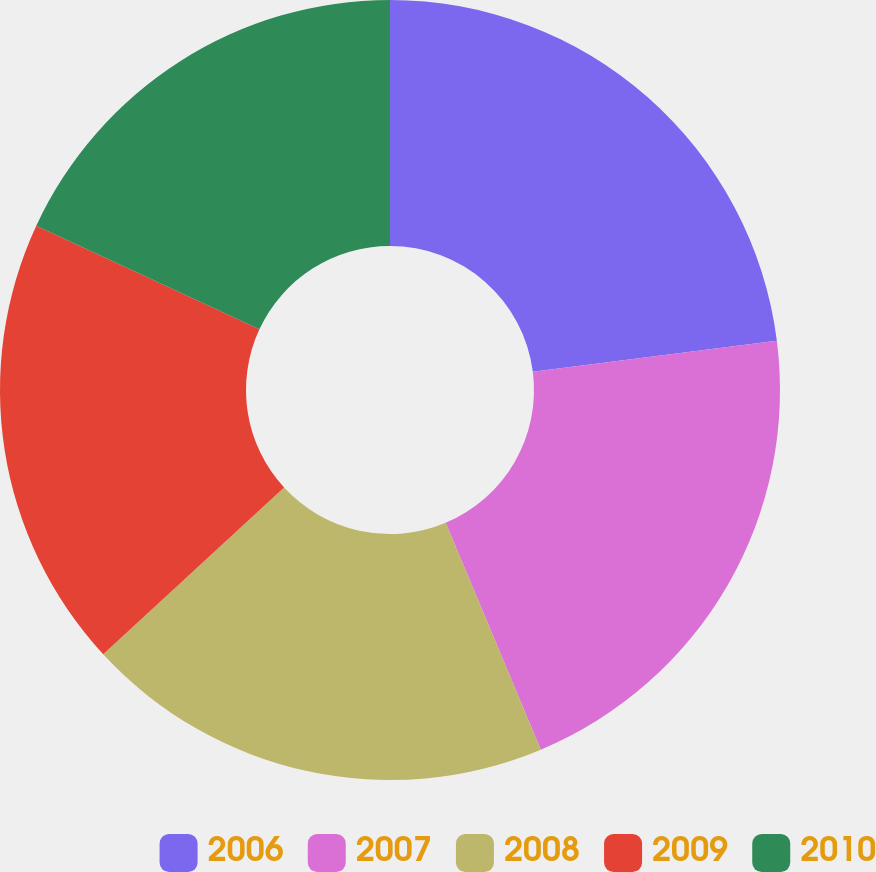<chart> <loc_0><loc_0><loc_500><loc_500><pie_chart><fcel>2006<fcel>2007<fcel>2008<fcel>2009<fcel>2010<nl><fcel>22.98%<fcel>20.7%<fcel>19.47%<fcel>18.77%<fcel>18.08%<nl></chart> 